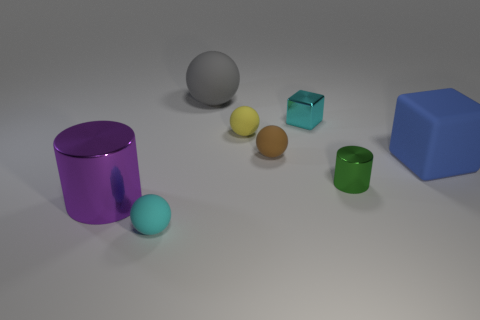Subtract all yellow matte spheres. How many spheres are left? 3 Add 2 cylinders. How many objects exist? 10 Subtract all gray spheres. How many spheres are left? 3 Subtract 2 cubes. How many cubes are left? 0 Subtract all blocks. How many objects are left? 6 Subtract 0 red spheres. How many objects are left? 8 Subtract all yellow cylinders. Subtract all green spheres. How many cylinders are left? 2 Subtract all blue cylinders. How many purple blocks are left? 0 Subtract all small rubber spheres. Subtract all purple metal cylinders. How many objects are left? 4 Add 6 big balls. How many big balls are left? 7 